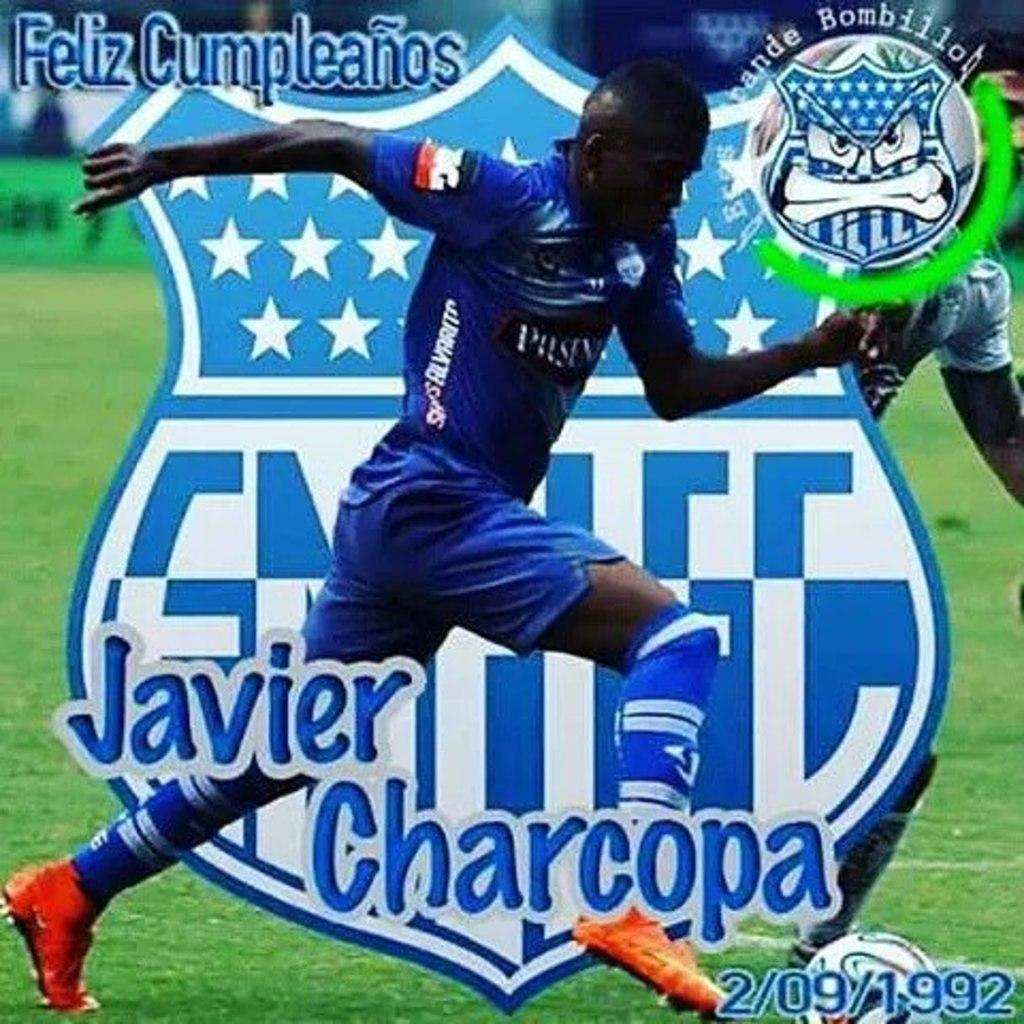Provide a one-sentence caption for the provided image. The player in the blue uniform is Javier Charcopa. 